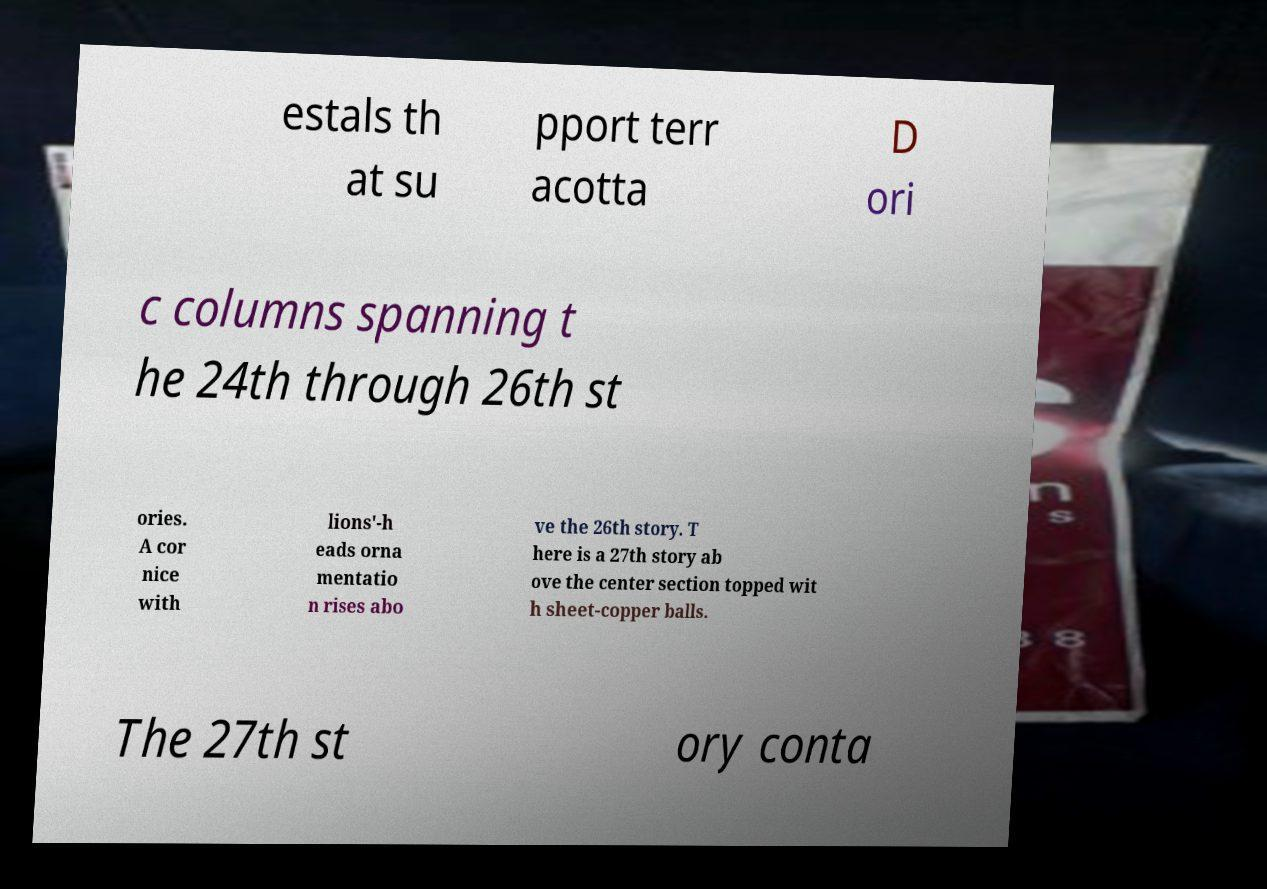What messages or text are displayed in this image? I need them in a readable, typed format. estals th at su pport terr acotta D ori c columns spanning t he 24th through 26th st ories. A cor nice with lions'-h eads orna mentatio n rises abo ve the 26th story. T here is a 27th story ab ove the center section topped wit h sheet-copper balls. The 27th st ory conta 